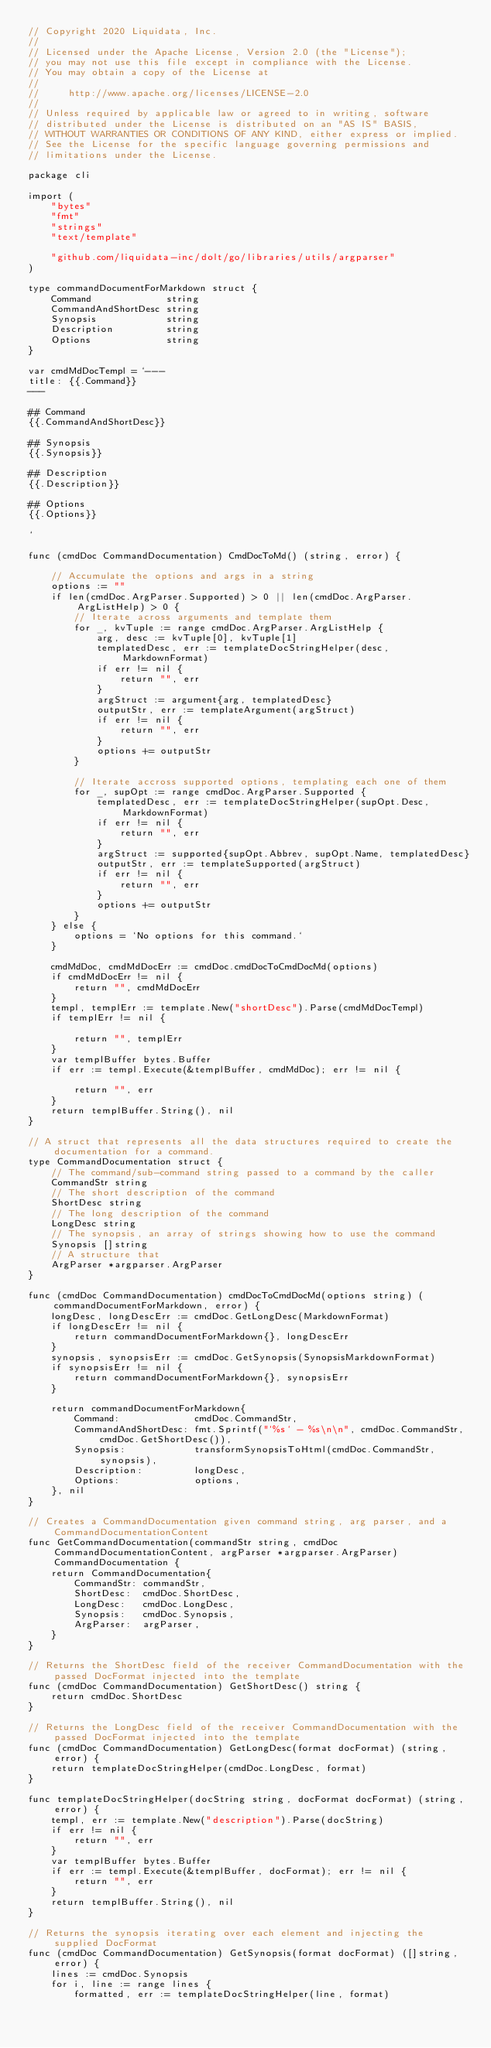<code> <loc_0><loc_0><loc_500><loc_500><_Go_>// Copyright 2020 Liquidata, Inc.
//
// Licensed under the Apache License, Version 2.0 (the "License");
// you may not use this file except in compliance with the License.
// You may obtain a copy of the License at
//
//     http://www.apache.org/licenses/LICENSE-2.0
//
// Unless required by applicable law or agreed to in writing, software
// distributed under the License is distributed on an "AS IS" BASIS,
// WITHOUT WARRANTIES OR CONDITIONS OF ANY KIND, either express or implied.
// See the License for the specific language governing permissions and
// limitations under the License.

package cli

import (
	"bytes"
	"fmt"
	"strings"
	"text/template"

	"github.com/liquidata-inc/dolt/go/libraries/utils/argparser"
)

type commandDocumentForMarkdown struct {
	Command             string
	CommandAndShortDesc string
	Synopsis            string
	Description         string
	Options             string
}

var cmdMdDocTempl = `---
title: {{.Command}}
---

## Command
{{.CommandAndShortDesc}}

## Synopsis
{{.Synopsis}}

## Description
{{.Description}}

## Options
{{.Options}}

`

func (cmdDoc CommandDocumentation) CmdDocToMd() (string, error) {

	// Accumulate the options and args in a string
	options := ""
	if len(cmdDoc.ArgParser.Supported) > 0 || len(cmdDoc.ArgParser.ArgListHelp) > 0 {
		// Iterate across arguments and template them
		for _, kvTuple := range cmdDoc.ArgParser.ArgListHelp {
			arg, desc := kvTuple[0], kvTuple[1]
			templatedDesc, err := templateDocStringHelper(desc, MarkdownFormat)
			if err != nil {
				return "", err
			}
			argStruct := argument{arg, templatedDesc}
			outputStr, err := templateArgument(argStruct)
			if err != nil {
				return "", err
			}
			options += outputStr
		}

		// Iterate accross supported options, templating each one of them
		for _, supOpt := range cmdDoc.ArgParser.Supported {
			templatedDesc, err := templateDocStringHelper(supOpt.Desc, MarkdownFormat)
			if err != nil {
				return "", err
			}
			argStruct := supported{supOpt.Abbrev, supOpt.Name, templatedDesc}
			outputStr, err := templateSupported(argStruct)
			if err != nil {
				return "", err
			}
			options += outputStr
		}
	} else {
		options = `No options for this command.`
	}

	cmdMdDoc, cmdMdDocErr := cmdDoc.cmdDocToCmdDocMd(options)
	if cmdMdDocErr != nil {
		return "", cmdMdDocErr
	}
	templ, templErr := template.New("shortDesc").Parse(cmdMdDocTempl)
	if templErr != nil {

		return "", templErr
	}
	var templBuffer bytes.Buffer
	if err := templ.Execute(&templBuffer, cmdMdDoc); err != nil {

		return "", err
	}
	return templBuffer.String(), nil
}

// A struct that represents all the data structures required to create the documentation for a command.
type CommandDocumentation struct {
	// The command/sub-command string passed to a command by the caller
	CommandStr string
	// The short description of the command
	ShortDesc string
	// The long description of the command
	LongDesc string
	// The synopsis, an array of strings showing how to use the command
	Synopsis []string
	// A structure that
	ArgParser *argparser.ArgParser
}

func (cmdDoc CommandDocumentation) cmdDocToCmdDocMd(options string) (commandDocumentForMarkdown, error) {
	longDesc, longDescErr := cmdDoc.GetLongDesc(MarkdownFormat)
	if longDescErr != nil {
		return commandDocumentForMarkdown{}, longDescErr
	}
	synopsis, synopsisErr := cmdDoc.GetSynopsis(SynopsisMarkdownFormat)
	if synopsisErr != nil {
		return commandDocumentForMarkdown{}, synopsisErr
	}

	return commandDocumentForMarkdown{
		Command:             cmdDoc.CommandStr,
		CommandAndShortDesc: fmt.Sprintf("`%s` - %s\n\n", cmdDoc.CommandStr, cmdDoc.GetShortDesc()),
		Synopsis:            transformSynopsisToHtml(cmdDoc.CommandStr, synopsis),
		Description:         longDesc,
		Options:             options,
	}, nil
}

// Creates a CommandDocumentation given command string, arg parser, and a CommandDocumentationContent
func GetCommandDocumentation(commandStr string, cmdDoc CommandDocumentationContent, argParser *argparser.ArgParser) CommandDocumentation {
	return CommandDocumentation{
		CommandStr: commandStr,
		ShortDesc:  cmdDoc.ShortDesc,
		LongDesc:   cmdDoc.LongDesc,
		Synopsis:   cmdDoc.Synopsis,
		ArgParser:  argParser,
	}
}

// Returns the ShortDesc field of the receiver CommandDocumentation with the passed DocFormat injected into the template
func (cmdDoc CommandDocumentation) GetShortDesc() string {
	return cmdDoc.ShortDesc
}

// Returns the LongDesc field of the receiver CommandDocumentation with the passed DocFormat injected into the template
func (cmdDoc CommandDocumentation) GetLongDesc(format docFormat) (string, error) {
	return templateDocStringHelper(cmdDoc.LongDesc, format)
}

func templateDocStringHelper(docString string, docFormat docFormat) (string, error) {
	templ, err := template.New("description").Parse(docString)
	if err != nil {
		return "", err
	}
	var templBuffer bytes.Buffer
	if err := templ.Execute(&templBuffer, docFormat); err != nil {
		return "", err
	}
	return templBuffer.String(), nil
}

// Returns the synopsis iterating over each element and injecting the supplied DocFormat
func (cmdDoc CommandDocumentation) GetSynopsis(format docFormat) ([]string, error) {
	lines := cmdDoc.Synopsis
	for i, line := range lines {
		formatted, err := templateDocStringHelper(line, format)</code> 